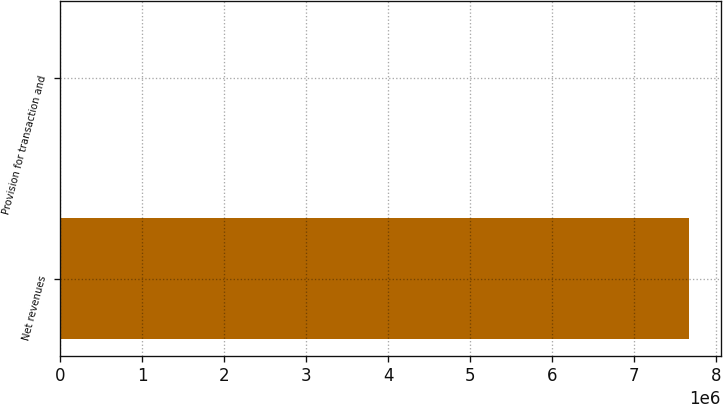Convert chart to OTSL. <chart><loc_0><loc_0><loc_500><loc_500><bar_chart><fcel>Net revenues<fcel>Provision for transaction and<nl><fcel>7.67233e+06<fcel>3.8<nl></chart> 